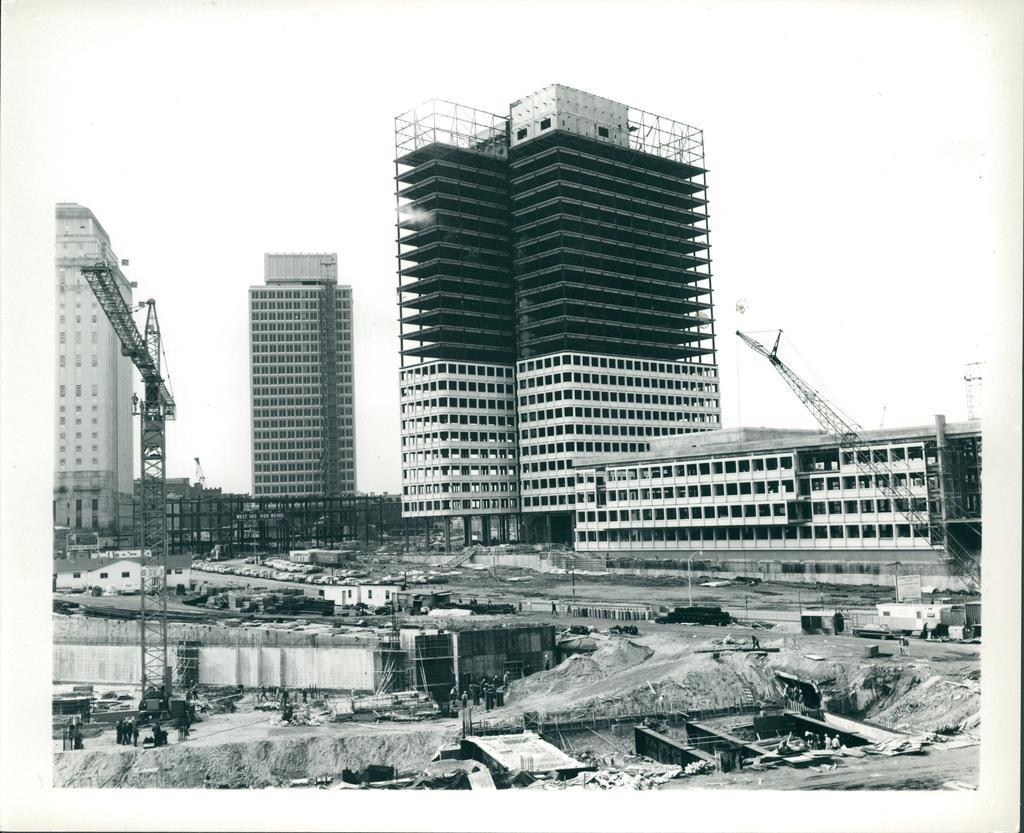What is the color scheme of the image? The image is black and white. What can be seen in the foreground of the image? There are raw materials, a crane, and other equipment in the foreground. What is visible in the background of the image? There are buildings and architectures in the background. How much does the produce weigh in the image? There is no produce present in the image; it features raw materials, a crane, and other equipment in the foreground. Can you hear the architectures crying in the background? The image is a still image, so there is no sound or indication of crying in the image. 